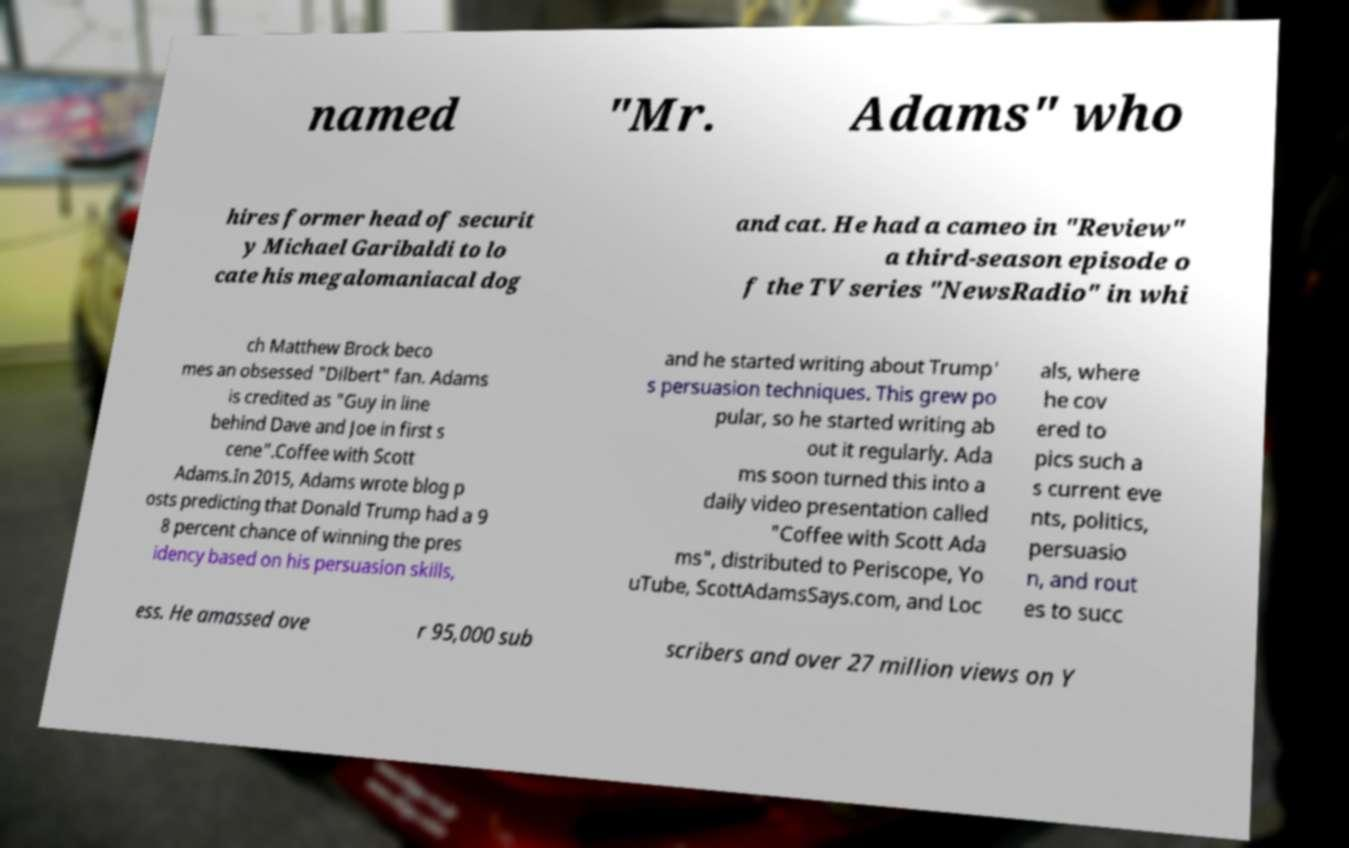Could you assist in decoding the text presented in this image and type it out clearly? named "Mr. Adams" who hires former head of securit y Michael Garibaldi to lo cate his megalomaniacal dog and cat. He had a cameo in "Review" a third-season episode o f the TV series "NewsRadio" in whi ch Matthew Brock beco mes an obsessed "Dilbert" fan. Adams is credited as "Guy in line behind Dave and Joe in first s cene".Coffee with Scott Adams.In 2015, Adams wrote blog p osts predicting that Donald Trump had a 9 8 percent chance of winning the pres idency based on his persuasion skills, and he started writing about Trump' s persuasion techniques. This grew po pular, so he started writing ab out it regularly. Ada ms soon turned this into a daily video presentation called "Coffee with Scott Ada ms", distributed to Periscope, Yo uTube, ScottAdamsSays.com, and Loc als, where he cov ered to pics such a s current eve nts, politics, persuasio n, and rout es to succ ess. He amassed ove r 95,000 sub scribers and over 27 million views on Y 